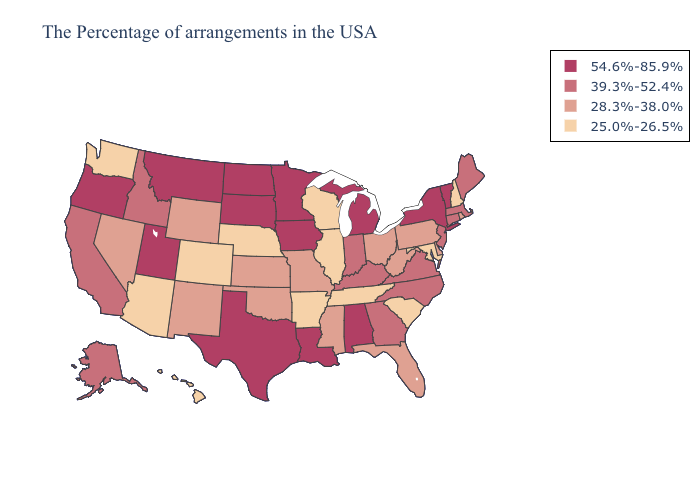Which states have the lowest value in the USA?
Be succinct. New Hampshire, Maryland, South Carolina, Tennessee, Wisconsin, Illinois, Arkansas, Nebraska, Colorado, Arizona, Washington, Hawaii. Does New York have the highest value in the Northeast?
Keep it brief. Yes. Does New Hampshire have the highest value in the Northeast?
Concise answer only. No. Name the states that have a value in the range 54.6%-85.9%?
Keep it brief. Vermont, New York, Michigan, Alabama, Louisiana, Minnesota, Iowa, Texas, South Dakota, North Dakota, Utah, Montana, Oregon. What is the value of Louisiana?
Quick response, please. 54.6%-85.9%. What is the lowest value in states that border Minnesota?
Short answer required. 25.0%-26.5%. What is the value of Ohio?
Quick response, please. 28.3%-38.0%. What is the highest value in states that border Colorado?
Give a very brief answer. 54.6%-85.9%. Among the states that border South Dakota , which have the lowest value?
Quick response, please. Nebraska. Does Florida have the same value as Missouri?
Keep it brief. Yes. What is the value of Connecticut?
Concise answer only. 39.3%-52.4%. Name the states that have a value in the range 25.0%-26.5%?
Write a very short answer. New Hampshire, Maryland, South Carolina, Tennessee, Wisconsin, Illinois, Arkansas, Nebraska, Colorado, Arizona, Washington, Hawaii. What is the lowest value in the USA?
Answer briefly. 25.0%-26.5%. Name the states that have a value in the range 54.6%-85.9%?
Be succinct. Vermont, New York, Michigan, Alabama, Louisiana, Minnesota, Iowa, Texas, South Dakota, North Dakota, Utah, Montana, Oregon. Name the states that have a value in the range 25.0%-26.5%?
Concise answer only. New Hampshire, Maryland, South Carolina, Tennessee, Wisconsin, Illinois, Arkansas, Nebraska, Colorado, Arizona, Washington, Hawaii. 